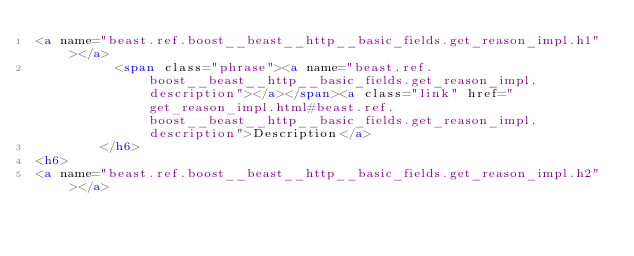<code> <loc_0><loc_0><loc_500><loc_500><_HTML_><a name="beast.ref.boost__beast__http__basic_fields.get_reason_impl.h1"></a>
          <span class="phrase"><a name="beast.ref.boost__beast__http__basic_fields.get_reason_impl.description"></a></span><a class="link" href="get_reason_impl.html#beast.ref.boost__beast__http__basic_fields.get_reason_impl.description">Description</a>
        </h6>
<h6>
<a name="beast.ref.boost__beast__http__basic_fields.get_reason_impl.h2"></a></code> 